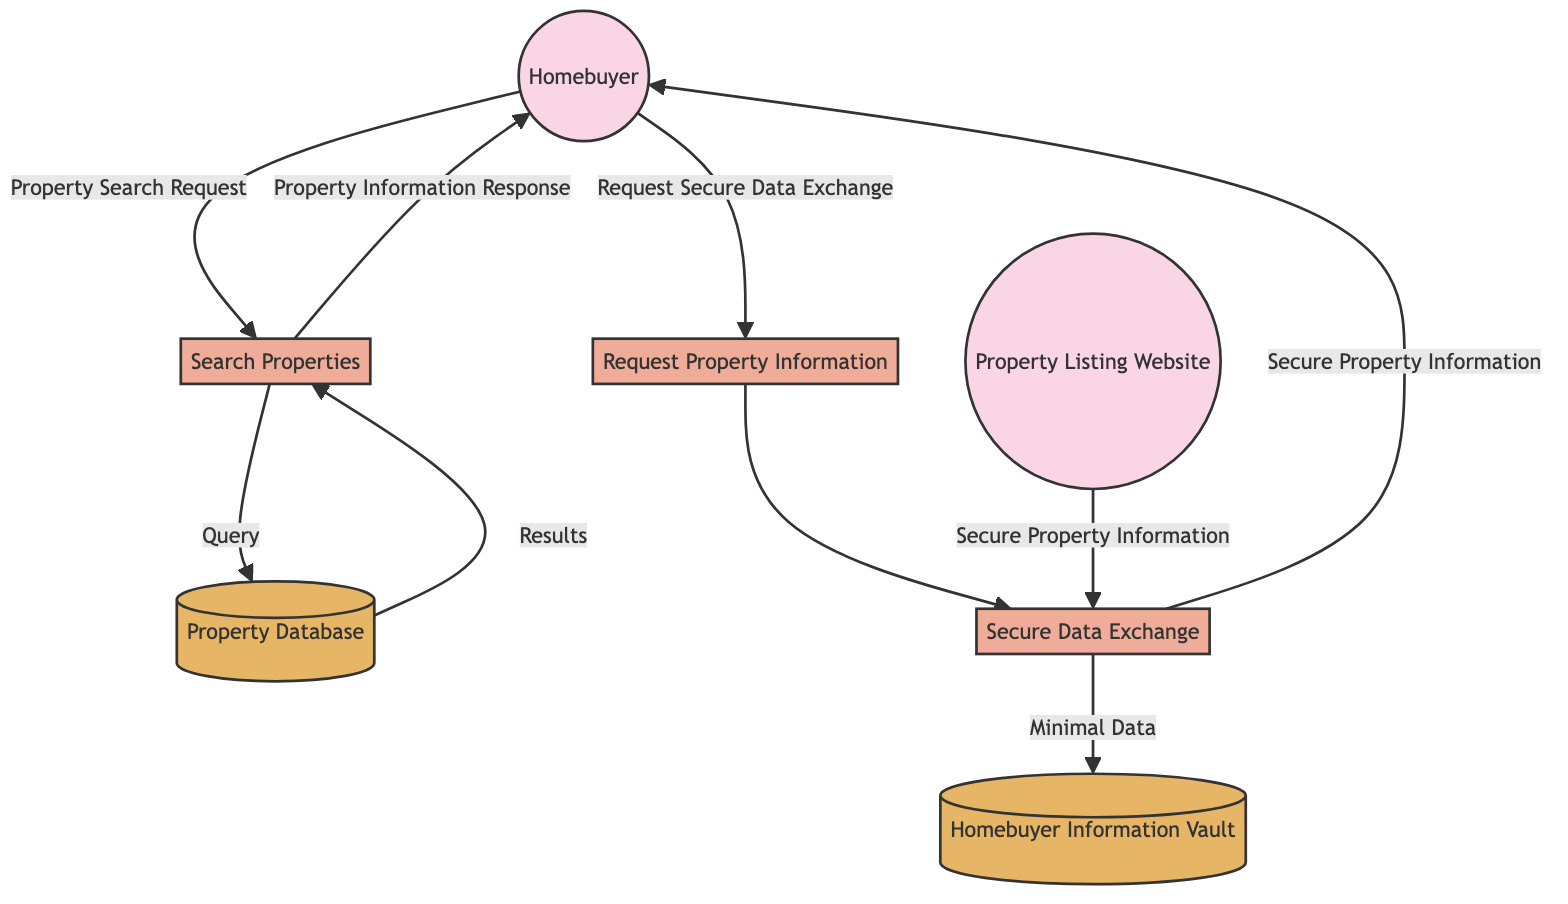what is the total number of external entities in the diagram? The diagram shows two external entities: Homebuyer and Property Listing Website.
Answer: 2 what is the name of the process that handles the homebuyer's search for properties? The process is labeled as "Search Properties", which indicates it is responsible for the homebuyer's action in searching for available listings.
Answer: Search Properties what is the data store that contains property details, images, and prices? The data store referred to in the diagram for storing property details is named "Property Database".
Answer: Property Database which process is responsible for the secure exchange of data? The process tasked with ensuring a secure exchange of data between the homebuyer and the property listing website is named "Secure Data Exchange".
Answer: Secure Data Exchange how does the homebuyer request detailed information about properties? The homebuyer requests detailed information about properties through the process labeled "Request Property Information". This indicates a designated route for the request of details.
Answer: Request Property Information what is the data flow that represents the request made by the homebuyer to search for properties? The data flow showcasing the request made by the homebuyer for property search criteria is labeled as "Property Search Request".
Answer: Property Search Request what type of information is kept in the "Homebuyer Information Vault"? The "Homebuyer Information Vault" is described as a secure storage system that holds "minimal personal information", suggesting it does not store extensive personal data.
Answer: Minimal personal information what is the purpose of the "Secure Data Exchange" process in the diagram? The purpose of the "Secure Data Exchange" process is to facilitate the transfer of details securely, as indicated in its description of being a secure mechanism for data transmission between involved parties.
Answer: Facilitate data transfer securely which external entity receives the "Secure Property Information"? The "Secure Property Information" is sent to the "Homebuyer", as indicated by the flow connection to this external entity.
Answer: Homebuyer 